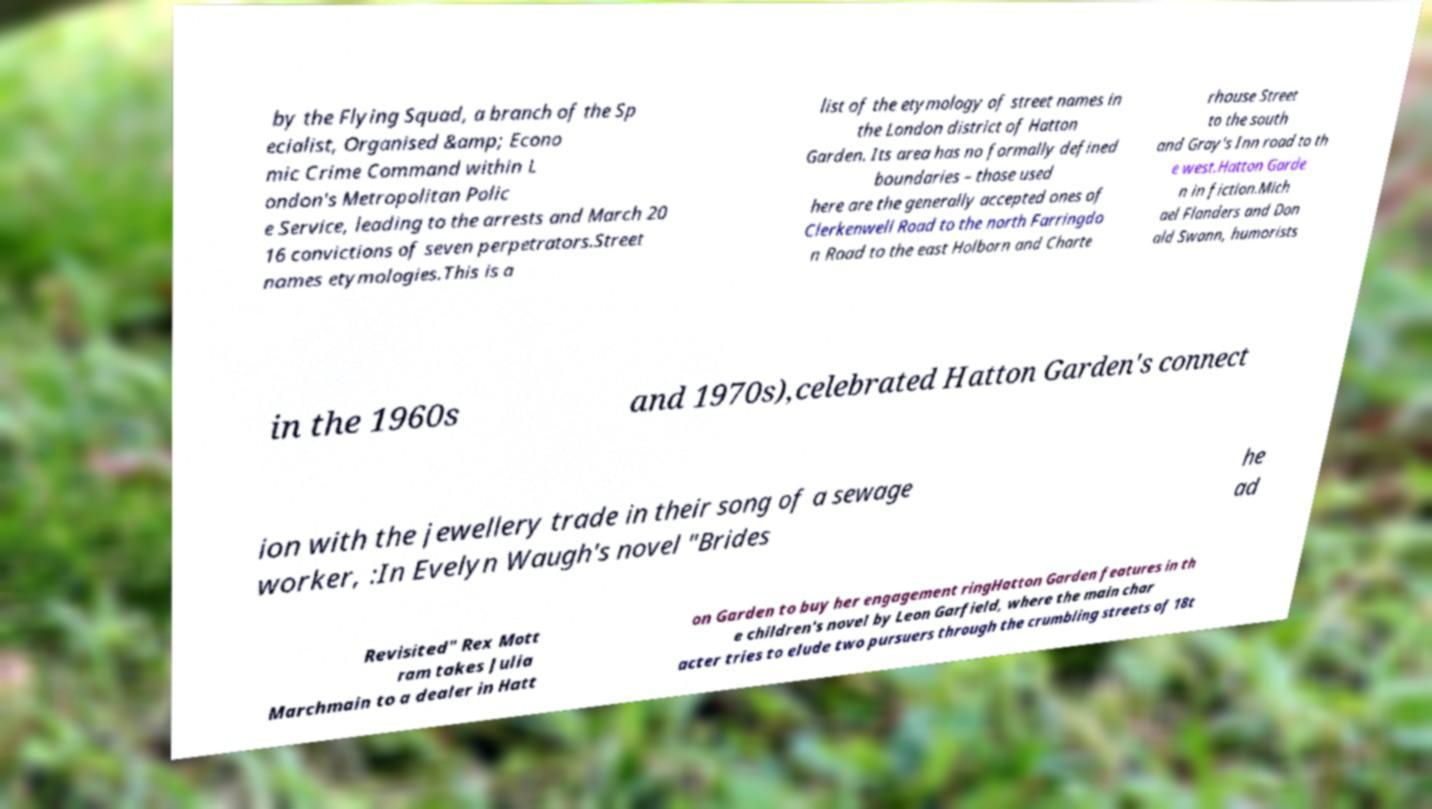Please read and relay the text visible in this image. What does it say? by the Flying Squad, a branch of the Sp ecialist, Organised &amp; Econo mic Crime Command within L ondon's Metropolitan Polic e Service, leading to the arrests and March 20 16 convictions of seven perpetrators.Street names etymologies.This is a list of the etymology of street names in the London district of Hatton Garden. Its area has no formally defined boundaries – those used here are the generally accepted ones of Clerkenwell Road to the north Farringdo n Road to the east Holborn and Charte rhouse Street to the south and Gray's Inn road to th e west.Hatton Garde n in fiction.Mich ael Flanders and Don ald Swann, humorists in the 1960s and 1970s),celebrated Hatton Garden's connect ion with the jewellery trade in their song of a sewage worker, :In Evelyn Waugh's novel "Brides he ad Revisited" Rex Mott ram takes Julia Marchmain to a dealer in Hatt on Garden to buy her engagement ringHatton Garden features in th e children's novel by Leon Garfield, where the main char acter tries to elude two pursuers through the crumbling streets of 18t 